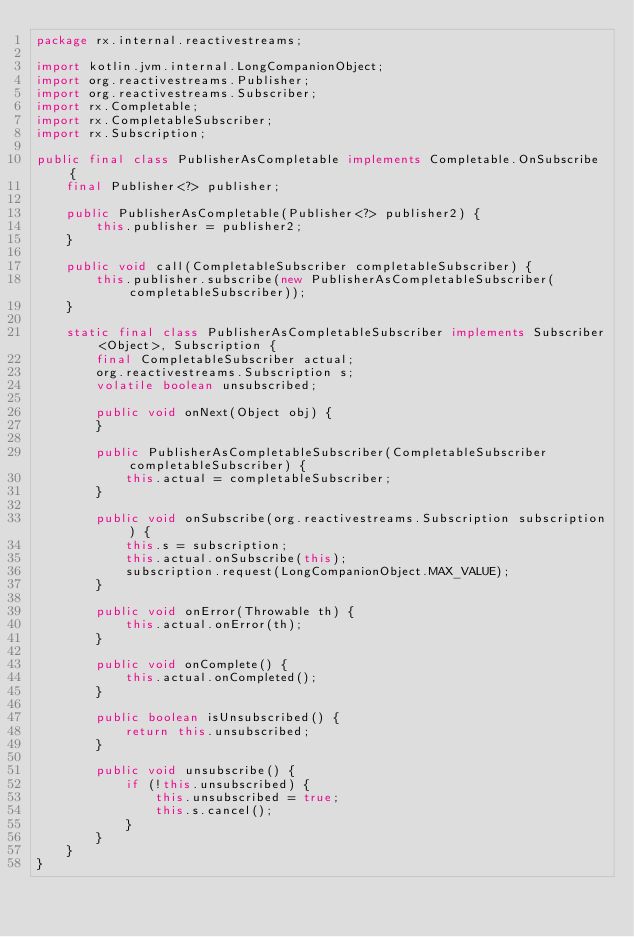<code> <loc_0><loc_0><loc_500><loc_500><_Java_>package rx.internal.reactivestreams;

import kotlin.jvm.internal.LongCompanionObject;
import org.reactivestreams.Publisher;
import org.reactivestreams.Subscriber;
import rx.Completable;
import rx.CompletableSubscriber;
import rx.Subscription;

public final class PublisherAsCompletable implements Completable.OnSubscribe {
    final Publisher<?> publisher;

    public PublisherAsCompletable(Publisher<?> publisher2) {
        this.publisher = publisher2;
    }

    public void call(CompletableSubscriber completableSubscriber) {
        this.publisher.subscribe(new PublisherAsCompletableSubscriber(completableSubscriber));
    }

    static final class PublisherAsCompletableSubscriber implements Subscriber<Object>, Subscription {
        final CompletableSubscriber actual;
        org.reactivestreams.Subscription s;
        volatile boolean unsubscribed;

        public void onNext(Object obj) {
        }

        public PublisherAsCompletableSubscriber(CompletableSubscriber completableSubscriber) {
            this.actual = completableSubscriber;
        }

        public void onSubscribe(org.reactivestreams.Subscription subscription) {
            this.s = subscription;
            this.actual.onSubscribe(this);
            subscription.request(LongCompanionObject.MAX_VALUE);
        }

        public void onError(Throwable th) {
            this.actual.onError(th);
        }

        public void onComplete() {
            this.actual.onCompleted();
        }

        public boolean isUnsubscribed() {
            return this.unsubscribed;
        }

        public void unsubscribe() {
            if (!this.unsubscribed) {
                this.unsubscribed = true;
                this.s.cancel();
            }
        }
    }
}
</code> 